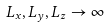<formula> <loc_0><loc_0><loc_500><loc_500>L _ { x } , L _ { y } , L _ { z } \rightarrow \infty</formula> 